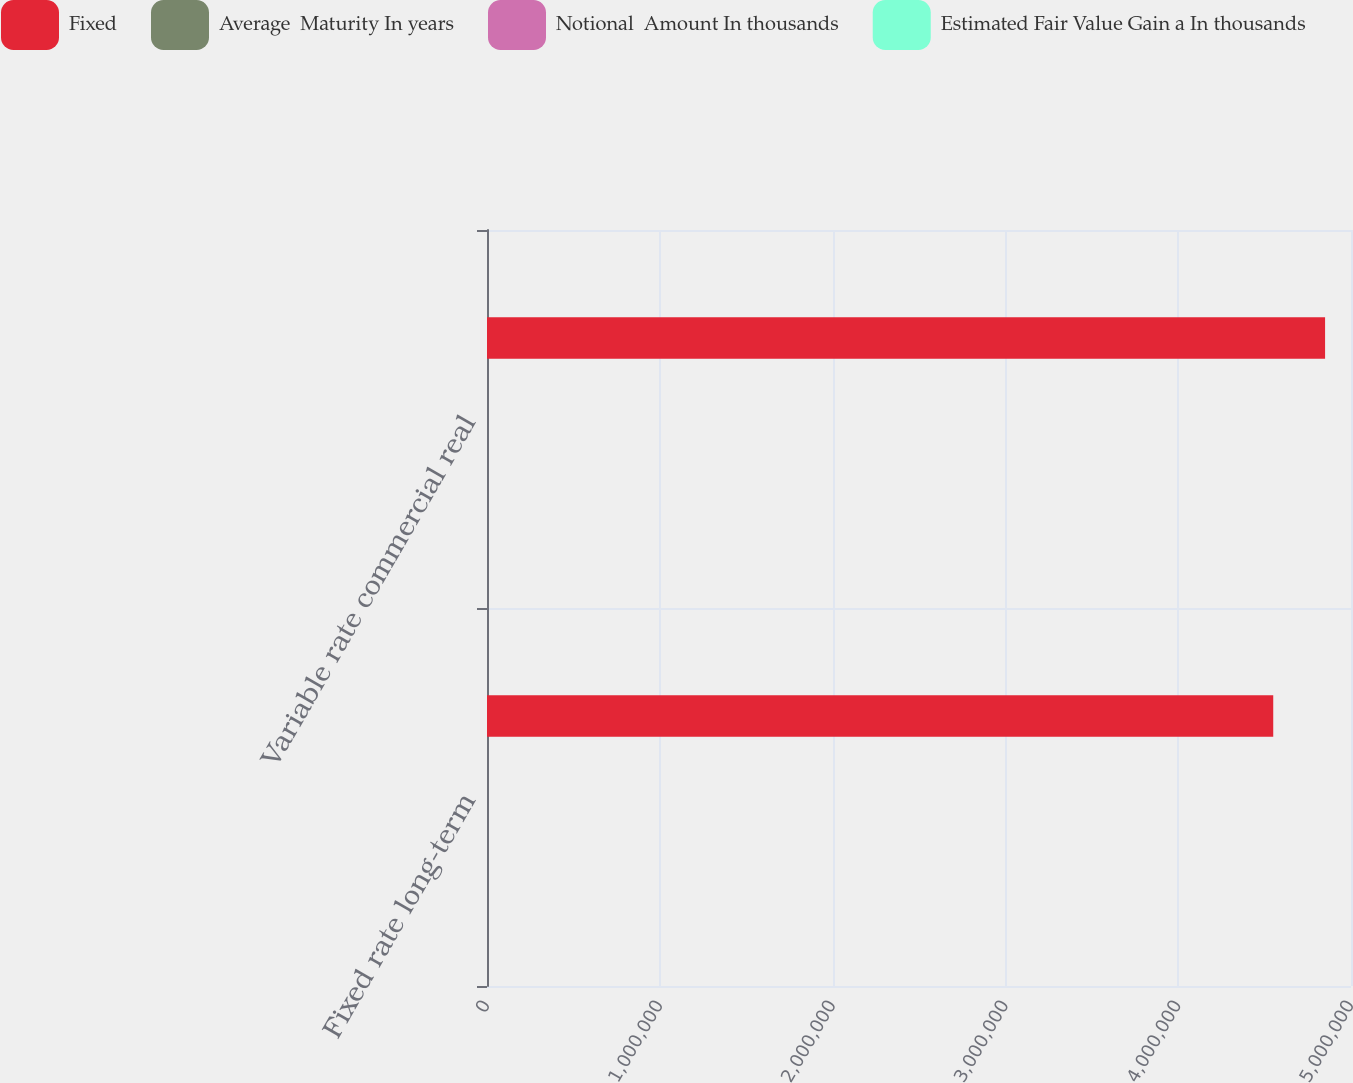Convert chart. <chart><loc_0><loc_0><loc_500><loc_500><stacked_bar_chart><ecel><fcel>Fixed rate long-term<fcel>Variable rate commercial real<nl><fcel>Fixed<fcel>4.55e+06<fcel>4.85e+06<nl><fcel>Average  Maturity In years<fcel>2.9<fcel>2<nl><fcel>Notional  Amount In thousands<fcel>2.27<fcel>1.52<nl><fcel>Estimated Fair Value Gain a In thousands<fcel>2.09<fcel>1.36<nl></chart> 